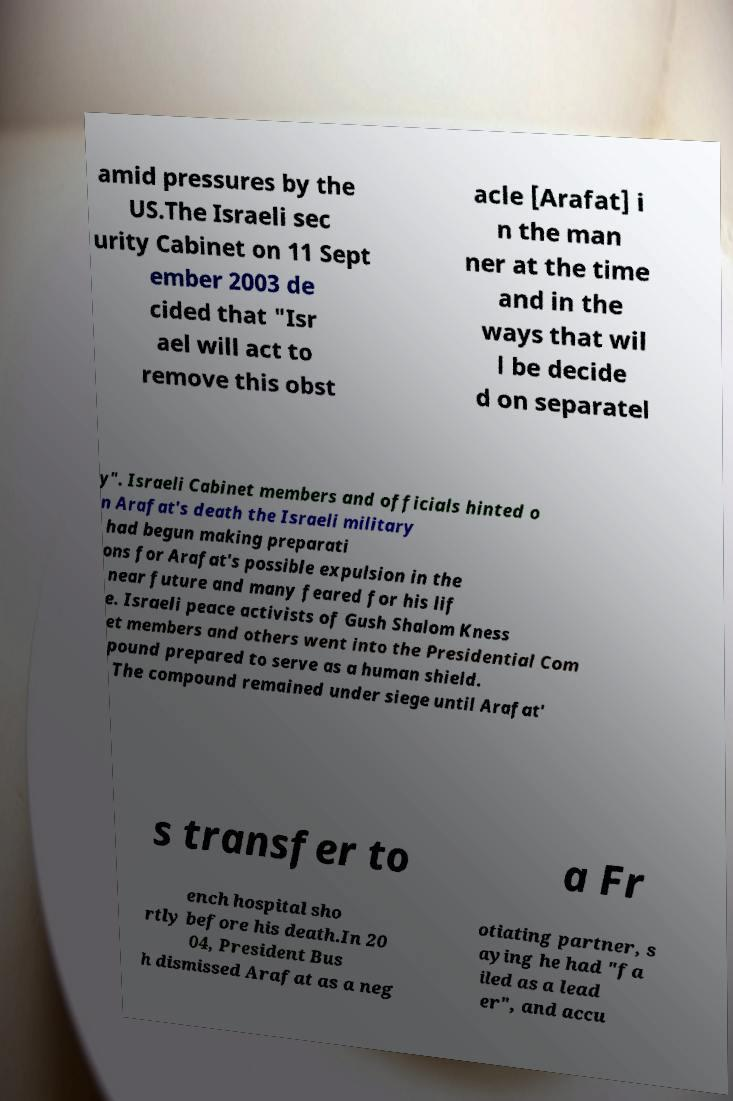Could you extract and type out the text from this image? amid pressures by the US.The Israeli sec urity Cabinet on 11 Sept ember 2003 de cided that "Isr ael will act to remove this obst acle [Arafat] i n the man ner at the time and in the ways that wil l be decide d on separatel y". Israeli Cabinet members and officials hinted o n Arafat's death the Israeli military had begun making preparati ons for Arafat's possible expulsion in the near future and many feared for his lif e. Israeli peace activists of Gush Shalom Kness et members and others went into the Presidential Com pound prepared to serve as a human shield. The compound remained under siege until Arafat' s transfer to a Fr ench hospital sho rtly before his death.In 20 04, President Bus h dismissed Arafat as a neg otiating partner, s aying he had "fa iled as a lead er", and accu 